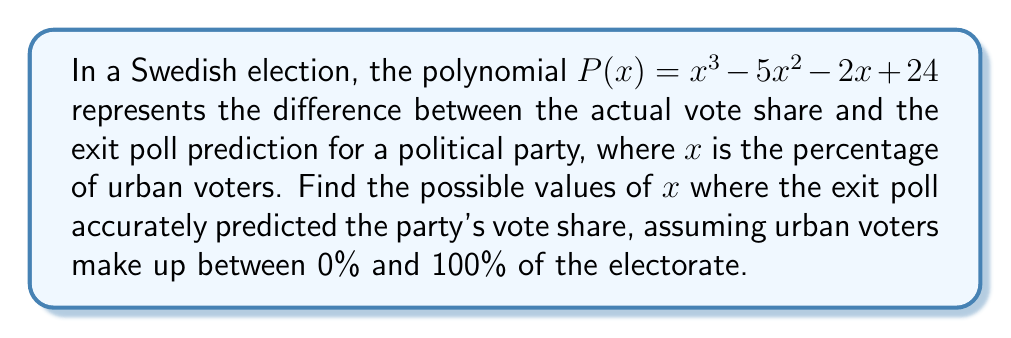Provide a solution to this math problem. To solve this problem, we need to follow these steps:

1) The exit poll is accurate when the difference between actual and predicted vote share is zero. This means we need to find the roots of the polynomial $P(x) = 0$.

2) Let's factor the polynomial $P(x) = x^3 - 5x^2 - 2x + 24$:

   First, let's check if there's a factor of the form $(x - a)$:
   $P(1) = 1 - 5 - 2 + 24 = 18$
   $P(2) = 8 - 20 - 4 + 24 = 8$
   $P(3) = 27 - 45 - 6 + 24 = 0$

   We found that $(x - 3)$ is a factor.

3) Divide $P(x)$ by $(x - 3)$:

   $x^3 - 5x^2 - 2x + 24 = (x - 3)(x^2 - 2x - 8)$

4) Now factor the quadratic term $x^2 - 2x - 8$:

   $x^2 - 2x - 8 = (x - 4)(x + 2)$

5) Therefore, the fully factored polynomial is:

   $P(x) = (x - 3)(x - 4)(x + 2)$

6) The roots of this polynomial are $x = 3$, $x = 4$, and $x = -2$.

7) Since $x$ represents a percentage, it must be between 0 and 100. Therefore, we can discard the negative root.

Thus, the exit poll accurately predicted the party's vote share when urban voters make up 3% or 4% of the electorate.
Answer: 3% and 4% 